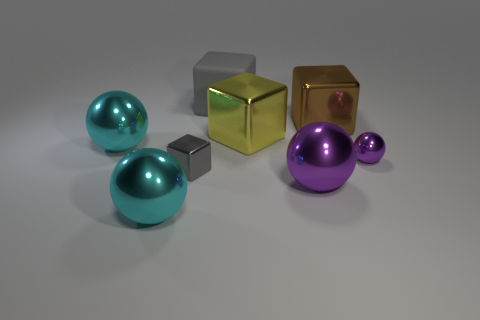Is the tiny block the same color as the matte cube?
Make the answer very short. Yes. Is the small ball made of the same material as the brown thing?
Your answer should be very brief. Yes. What number of large objects have the same material as the small gray cube?
Your answer should be very brief. 5. What is the color of the small ball that is the same material as the big purple thing?
Ensure brevity in your answer.  Purple. The brown metal object has what shape?
Offer a terse response. Cube. There is a cyan ball that is in front of the large purple ball; what is it made of?
Keep it short and to the point. Metal. Is there a small shiny block that has the same color as the matte thing?
Your answer should be compact. Yes. There is a yellow thing that is the same size as the brown metallic thing; what is its shape?
Provide a short and direct response. Cube. What is the color of the metal cube that is in front of the small purple ball?
Offer a terse response. Gray. There is a small object to the left of the brown thing; is there a metallic object that is to the left of it?
Your answer should be very brief. Yes. 